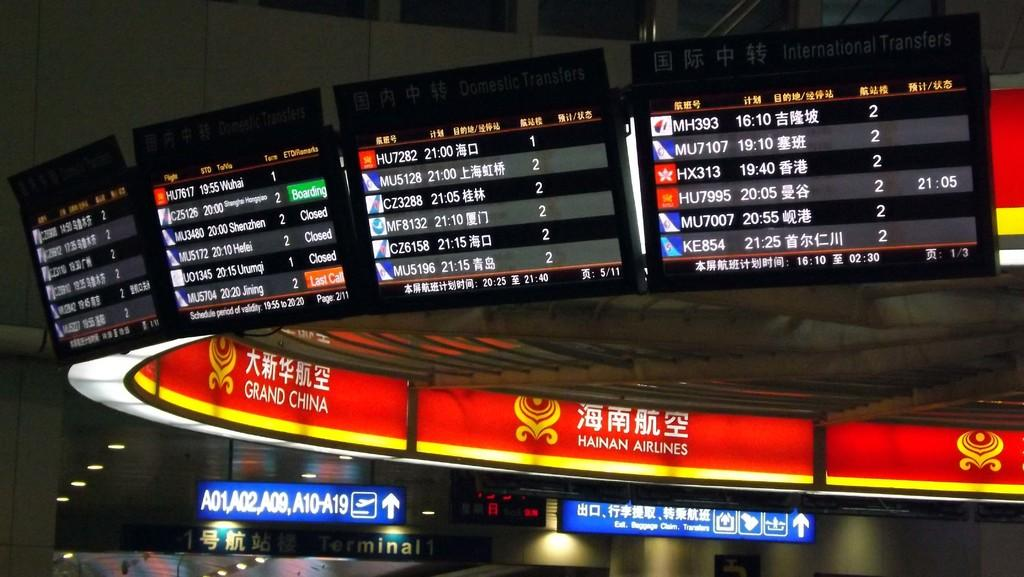Provide a one-sentence caption for the provided image. Flight departure and incoming boards show that several flights including HU7282 that is scheduled for 21:00 and MU5128 that is scheduled for 21:00. 